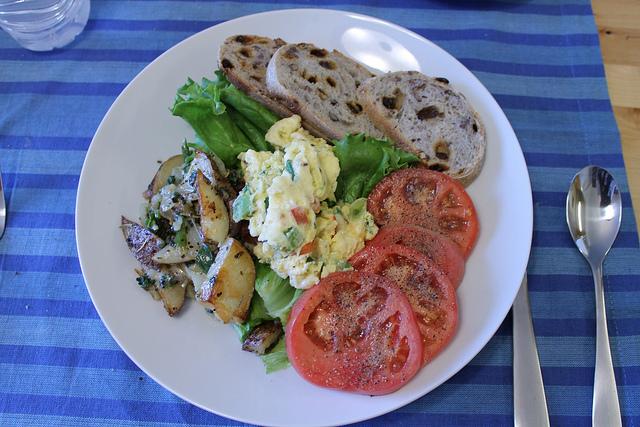What spice is on the tomatoes?
Answer briefly. Pepper. Does the bread have a soft or crunchy crust?
Write a very short answer. Soft. Is there a tablecloth on the table?
Answer briefly. No. What utensil can be seen?
Be succinct. Spoon. 